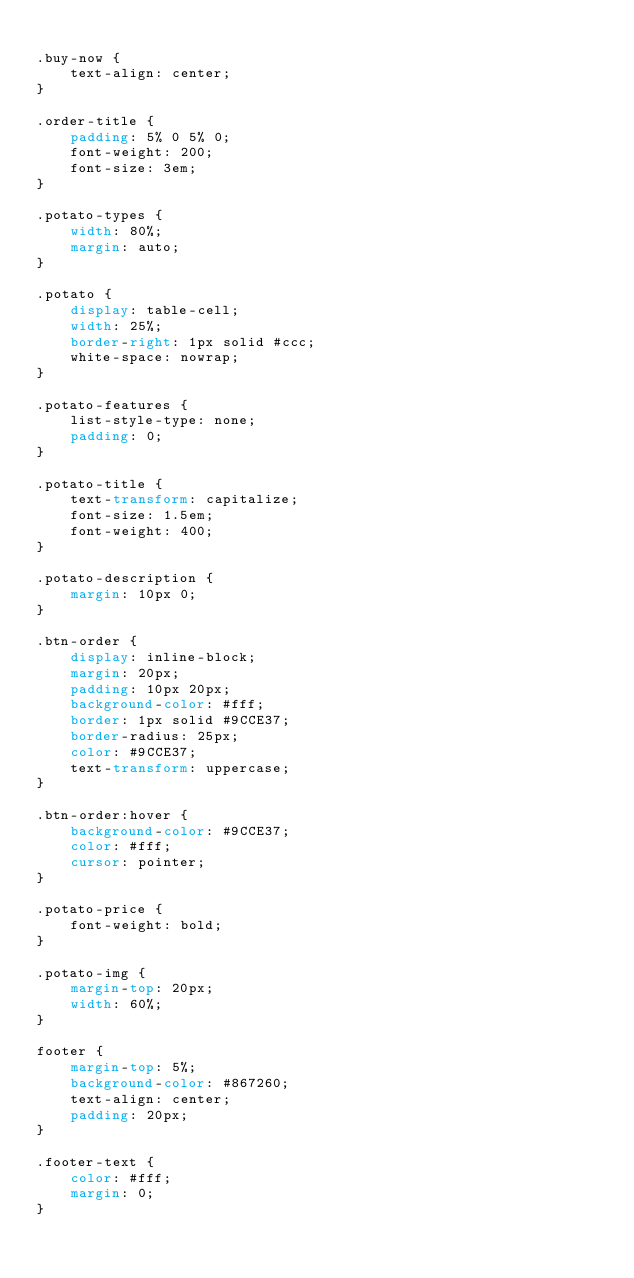<code> <loc_0><loc_0><loc_500><loc_500><_CSS_>
.buy-now {
    text-align: center;
}

.order-title {
    padding: 5% 0 5% 0;
    font-weight: 200;
    font-size: 3em;
}

.potato-types {
    width: 80%;
    margin: auto;
}

.potato {
    display: table-cell;
    width: 25%;
    border-right: 1px solid #ccc;
    white-space: nowrap;
}

.potato-features {
    list-style-type: none;
    padding: 0;
}

.potato-title {
    text-transform: capitalize;
    font-size: 1.5em;
    font-weight: 400;
}

.potato-description {
    margin: 10px 0;
}

.btn-order {
    display: inline-block;
    margin: 20px;
    padding: 10px 20px;
    background-color: #fff;
    border: 1px solid #9CCE37;
    border-radius: 25px;
    color: #9CCE37;
    text-transform: uppercase;
}

.btn-order:hover {
    background-color: #9CCE37;
    color: #fff;
    cursor: pointer;
}

.potato-price {
    font-weight: bold;
}

.potato-img {
    margin-top: 20px;
    width: 60%;
}

footer {
    margin-top: 5%;
    background-color: #867260;
    text-align: center;
    padding: 20px;
}

.footer-text {
    color: #fff;
    margin: 0;
}</code> 